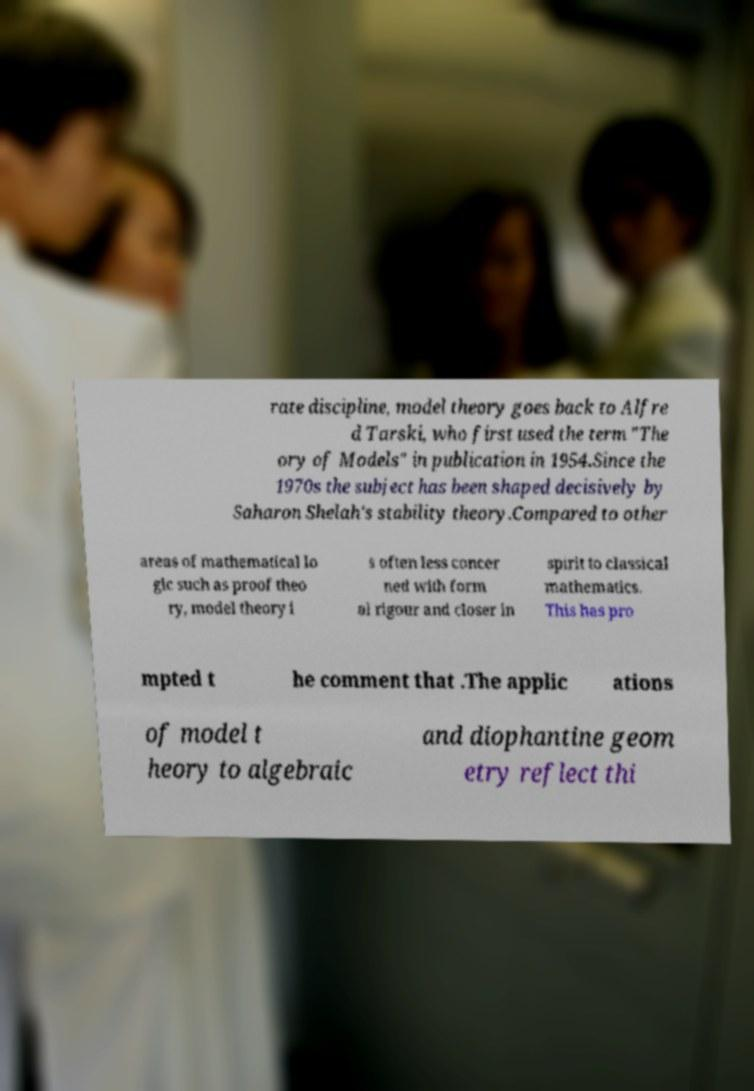Could you assist in decoding the text presented in this image and type it out clearly? rate discipline, model theory goes back to Alfre d Tarski, who first used the term "The ory of Models" in publication in 1954.Since the 1970s the subject has been shaped decisively by Saharon Shelah's stability theory.Compared to other areas of mathematical lo gic such as proof theo ry, model theory i s often less concer ned with form al rigour and closer in spirit to classical mathematics. This has pro mpted t he comment that .The applic ations of model t heory to algebraic and diophantine geom etry reflect thi 